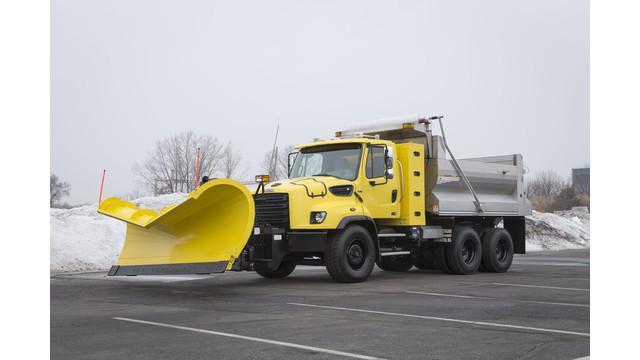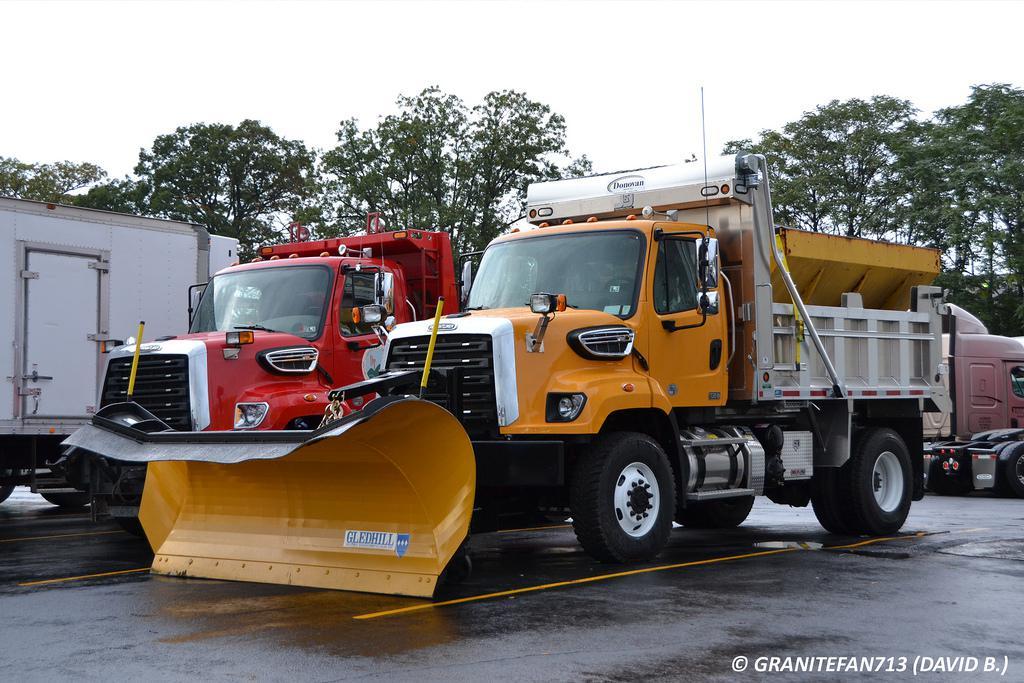The first image is the image on the left, the second image is the image on the right. Evaluate the accuracy of this statement regarding the images: "All plows shown feature the same color, and in the right image, a truck the same color as its plow is aimed rightward at an angle.". Is it true? Answer yes or no. No. The first image is the image on the left, the second image is the image on the right. For the images shown, is this caption "One snow plow is plowing snow." true? Answer yes or no. No. 